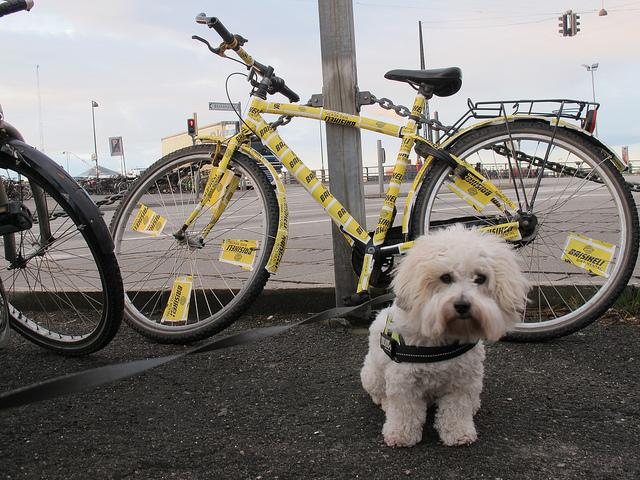Has the dog been chained?
Answer briefly. No. How many bikes are in the picture?
Give a very brief answer. 2. What color is the bike?
Quick response, please. Yellow. 